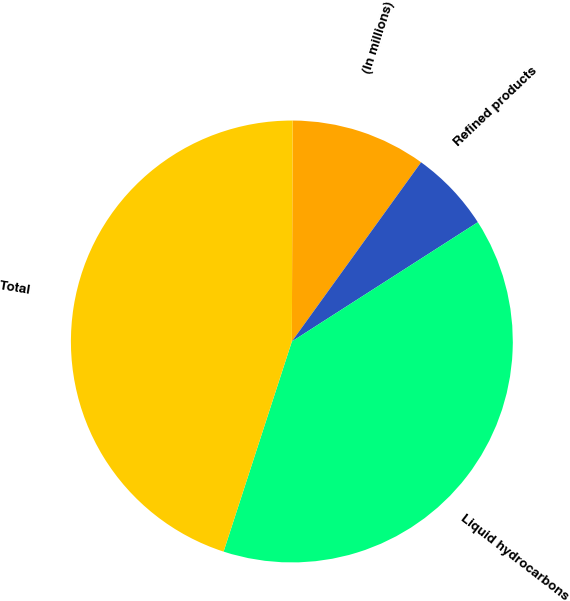Convert chart to OTSL. <chart><loc_0><loc_0><loc_500><loc_500><pie_chart><fcel>(In millions)<fcel>Refined products<fcel>Liquid hydrocarbons<fcel>Total<nl><fcel>9.89%<fcel>5.98%<fcel>39.08%<fcel>45.06%<nl></chart> 